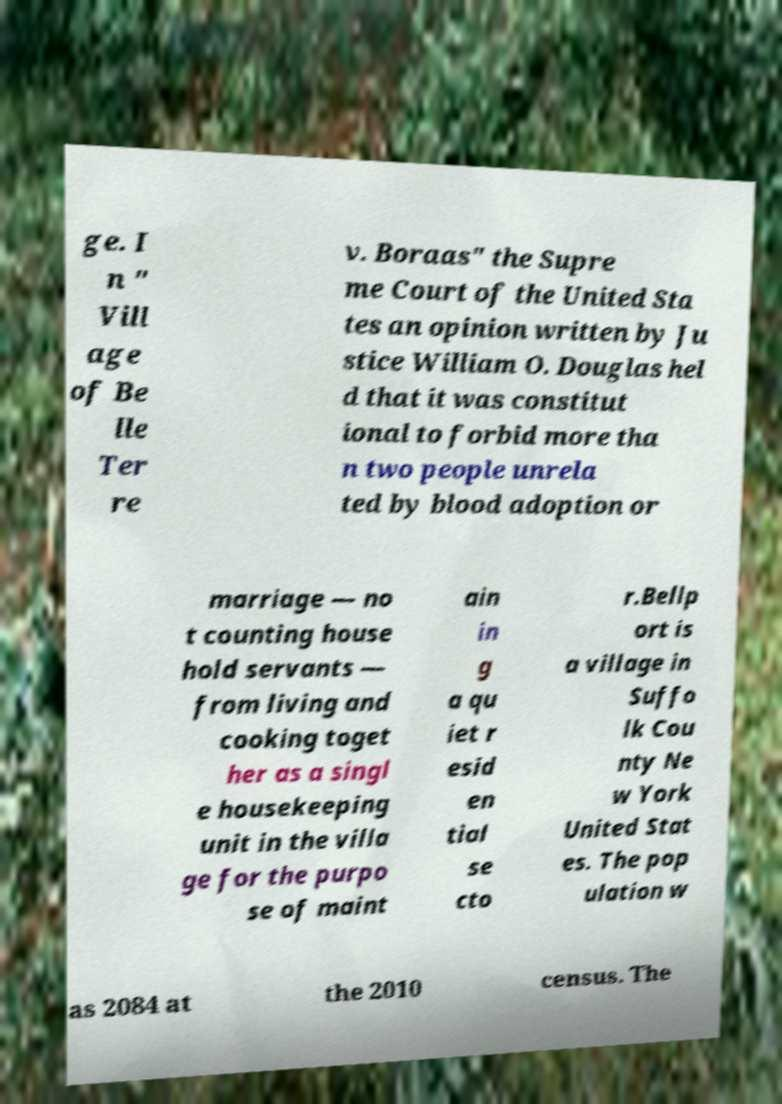For documentation purposes, I need the text within this image transcribed. Could you provide that? ge. I n " Vill age of Be lle Ter re v. Boraas" the Supre me Court of the United Sta tes an opinion written by Ju stice William O. Douglas hel d that it was constitut ional to forbid more tha n two people unrela ted by blood adoption or marriage — no t counting house hold servants — from living and cooking toget her as a singl e housekeeping unit in the villa ge for the purpo se of maint ain in g a qu iet r esid en tial se cto r.Bellp ort is a village in Suffo lk Cou nty Ne w York United Stat es. The pop ulation w as 2084 at the 2010 census. The 